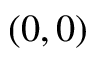Convert formula to latex. <formula><loc_0><loc_0><loc_500><loc_500>( 0 , 0 )</formula> 